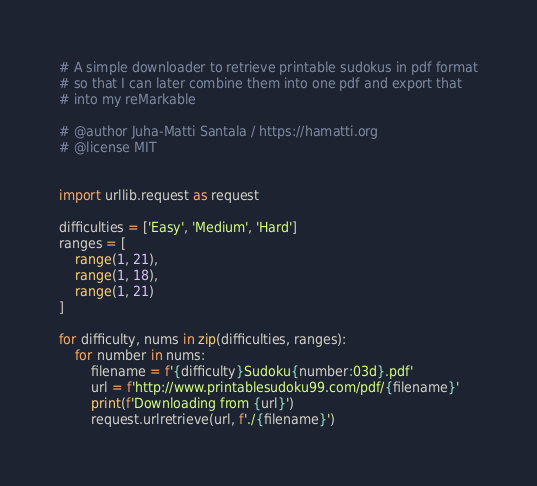Convert code to text. <code><loc_0><loc_0><loc_500><loc_500><_Python_># A simple downloader to retrieve printable sudokus in pdf format
# so that I can later combine them into one pdf and export that
# into my reMarkable

# @author Juha-Matti Santala / https://hamatti.org
# @license MIT


import urllib.request as request

difficulties = ['Easy', 'Medium', 'Hard']
ranges = [
    range(1, 21),
    range(1, 18),
    range(1, 21)
]

for difficulty, nums in zip(difficulties, ranges):
    for number in nums:
        filename = f'{difficulty}Sudoku{number:03d}.pdf'
        url = f'http://www.printablesudoku99.com/pdf/{filename}'
        print(f'Downloading from {url}')
        request.urlretrieve(url, f'./{filename}')
</code> 